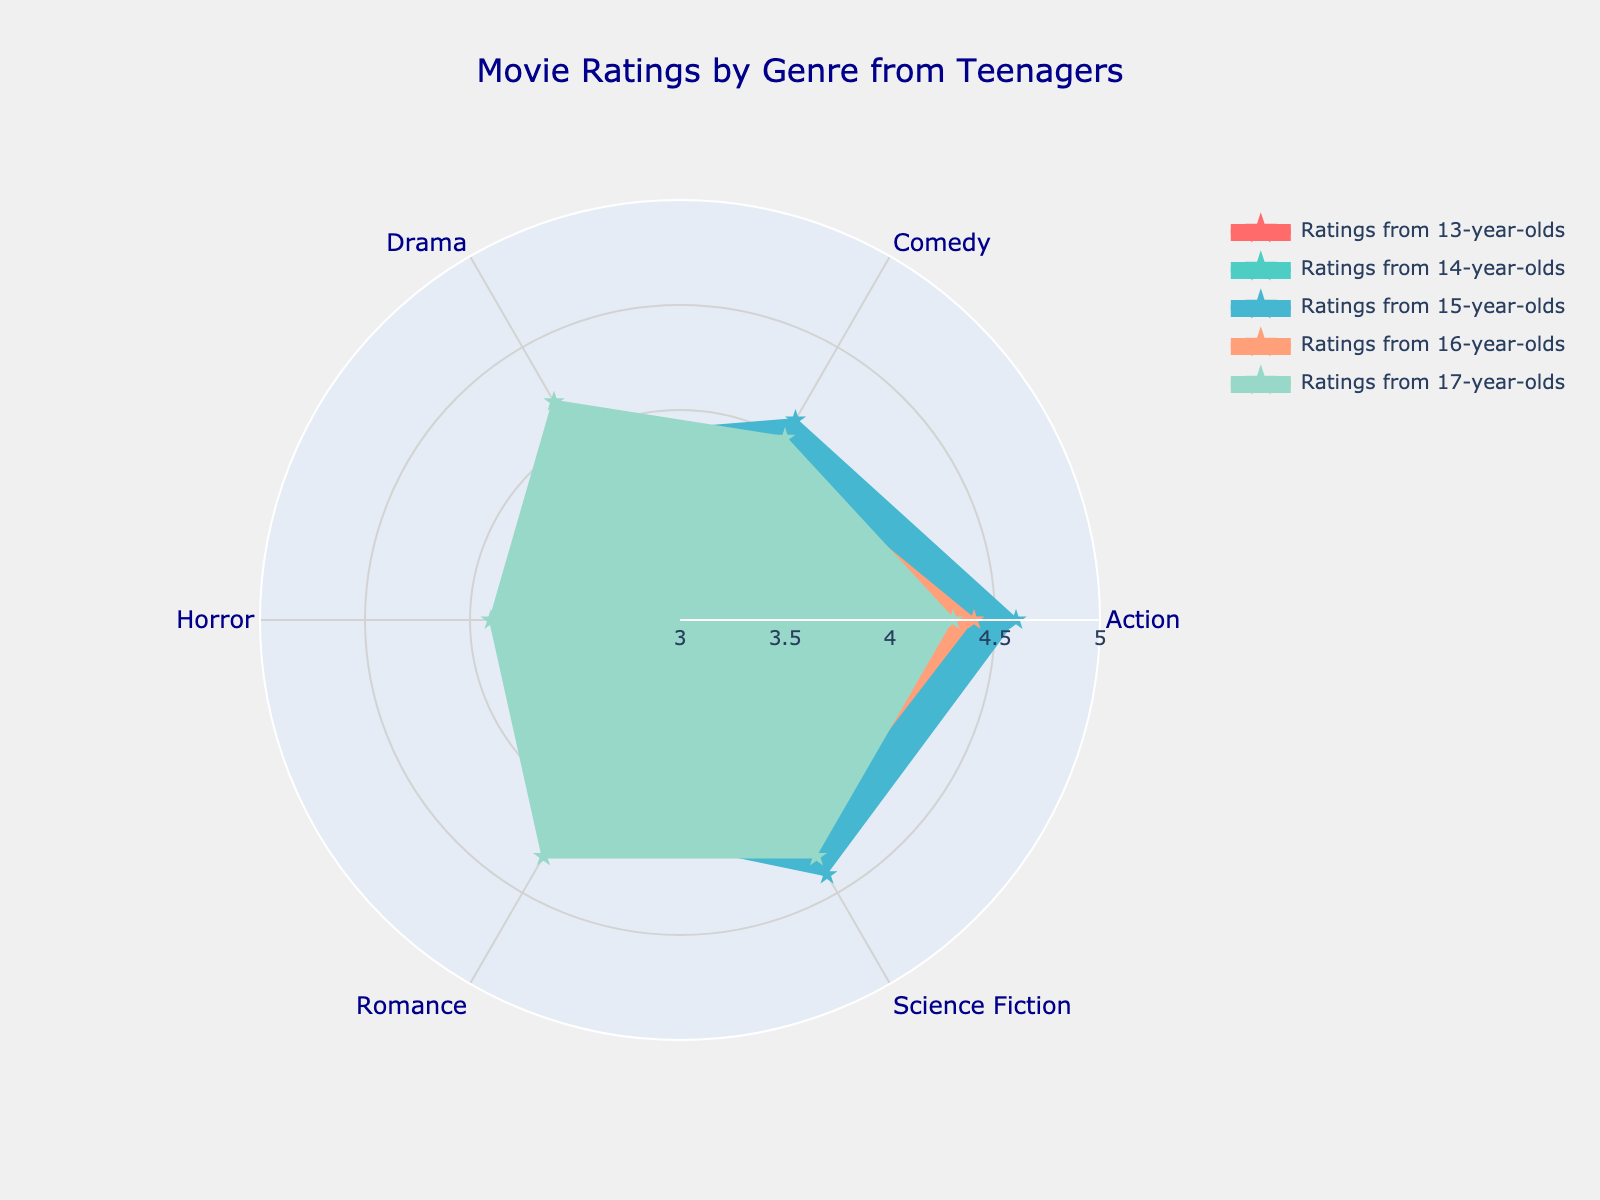What is the color scheme used for the different genres in the chart? The chart uses the following colors for the genres: '#FF6B6B' for the first genre, '#4ECDC4' for the second, '#45B7D1' for the third, '#FFA07A' for the fourth, '#98D8C8' for the fifth, and '#F7DC6F' for the sixth genre.
Answer: '#FF6B6B', '#4ECDC4', '#45B7D1', '#FFA07A', '#98D8C8', '#F7DC6F' Which genre received the highest rating from 17-year-olds? By observing the data points for 17-year-olds in the figure, the genre with the highest rating can be identified as having the largest radial value.
Answer: Drama Among 14-year-olds, which genre had the lowest rating, and what was that rating? The radial values for 14-year-olds need to be examined, and the genre with the smallest radial value is identified as the lowest-rated genre.
Answer: Horror, 3.5 How does the average rating of Science Fiction movies change from 13-year-olds to 17-year-olds? To find the average rating, add the ratings for each age group for Science Fiction and divide by the number of age groups: (4.1 + 4.3 + 4.4 + 4.2 + 4.3) / 5.
Answer: Average is 4.26 Which age group rated Action movies the highest, and what was the rating? By comparing the radial lengths for Action movies across all age groups, the age group with the longest radial line rating will be identified.
Answer: 15-year-olds, 4.6 Compare the ratings for Comedy movies from 15-year-olds and 16-year-olds. Who rated it higher, and by how much? Compare the radial lengths for Comedy between the two age groups to determine which one is higher and calculate the difference.
Answer: 15-year-olds rated it higher by 0.2 Is there any genre that was rated equally by 15-year-olds and 17-year-olds? Compare the radial lengths for each genre between 15-year-olds and 17-year-olds to see if any genres have equal ratings.
Answer: Science Fiction Which genre has the most significant variation in ratings among different age groups? Look for the genre with the highest difference between its maximum and minimum ratings across all age groups. Calculate the range for each genre and compare them.
Answer: Science Fiction What is the total sum of ratings for Romance movies across all age groups? Add the ratings for Romance movies from all age groups: 3.8 + 4.0 + 4.1 + 4.2 + 4.3.
Answer: 20.4 